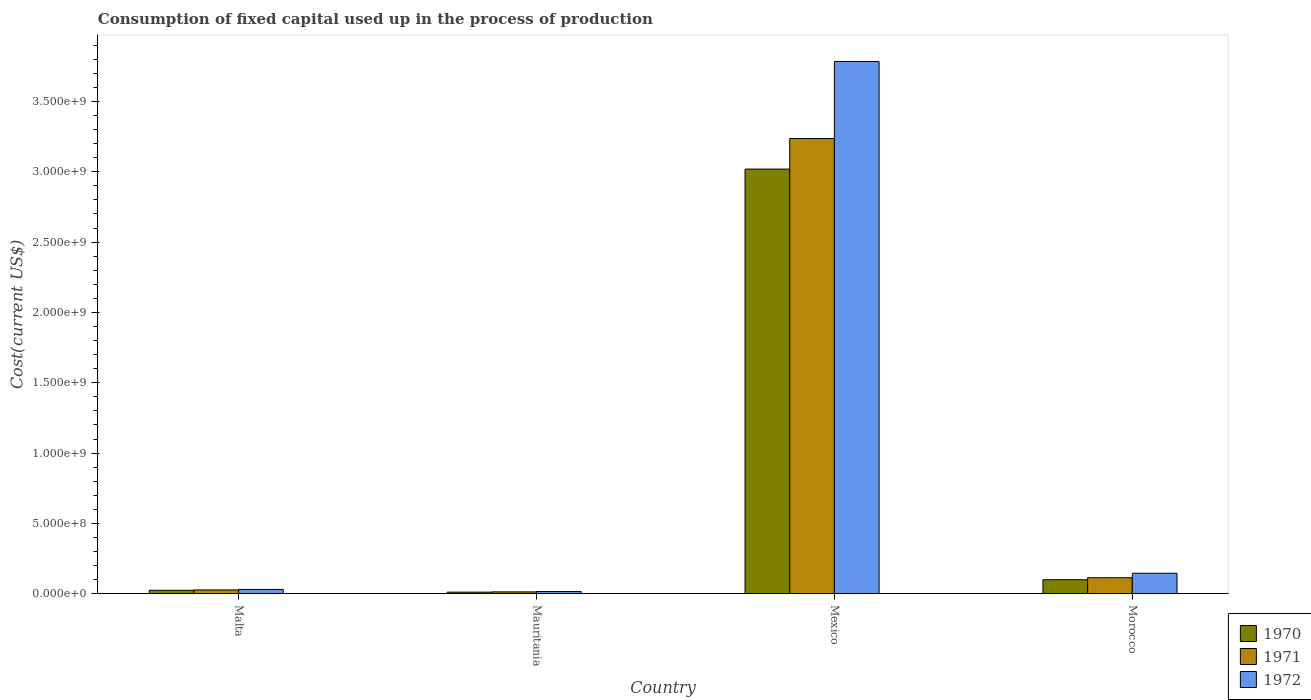In how many cases, is the number of bars for a given country not equal to the number of legend labels?
Give a very brief answer. 0. What is the amount consumed in the process of production in 1972 in Mauritania?
Your answer should be compact. 1.58e+07. Across all countries, what is the maximum amount consumed in the process of production in 1970?
Give a very brief answer. 3.02e+09. Across all countries, what is the minimum amount consumed in the process of production in 1971?
Offer a very short reply. 1.33e+07. In which country was the amount consumed in the process of production in 1970 minimum?
Your answer should be very brief. Mauritania. What is the total amount consumed in the process of production in 1971 in the graph?
Keep it short and to the point. 3.39e+09. What is the difference between the amount consumed in the process of production in 1971 in Mauritania and that in Mexico?
Offer a terse response. -3.22e+09. What is the difference between the amount consumed in the process of production in 1972 in Mexico and the amount consumed in the process of production in 1970 in Mauritania?
Ensure brevity in your answer.  3.77e+09. What is the average amount consumed in the process of production in 1970 per country?
Your answer should be compact. 7.89e+08. What is the difference between the amount consumed in the process of production of/in 1971 and amount consumed in the process of production of/in 1970 in Mauritania?
Offer a very short reply. 1.80e+06. In how many countries, is the amount consumed in the process of production in 1971 greater than 800000000 US$?
Your response must be concise. 1. What is the ratio of the amount consumed in the process of production in 1970 in Mauritania to that in Morocco?
Keep it short and to the point. 0.12. Is the difference between the amount consumed in the process of production in 1971 in Malta and Mexico greater than the difference between the amount consumed in the process of production in 1970 in Malta and Mexico?
Provide a short and direct response. No. What is the difference between the highest and the second highest amount consumed in the process of production in 1971?
Ensure brevity in your answer.  3.12e+09. What is the difference between the highest and the lowest amount consumed in the process of production in 1972?
Offer a very short reply. 3.77e+09. How many bars are there?
Make the answer very short. 12. Are all the bars in the graph horizontal?
Provide a short and direct response. No. Are the values on the major ticks of Y-axis written in scientific E-notation?
Ensure brevity in your answer.  Yes. Does the graph contain grids?
Offer a terse response. No. Where does the legend appear in the graph?
Provide a short and direct response. Bottom right. How are the legend labels stacked?
Provide a short and direct response. Vertical. What is the title of the graph?
Provide a short and direct response. Consumption of fixed capital used up in the process of production. What is the label or title of the Y-axis?
Provide a succinct answer. Cost(current US$). What is the Cost(current US$) in 1970 in Malta?
Provide a short and direct response. 2.47e+07. What is the Cost(current US$) of 1971 in Malta?
Your answer should be compact. 2.71e+07. What is the Cost(current US$) in 1972 in Malta?
Give a very brief answer. 3.06e+07. What is the Cost(current US$) of 1970 in Mauritania?
Offer a very short reply. 1.15e+07. What is the Cost(current US$) of 1971 in Mauritania?
Give a very brief answer. 1.33e+07. What is the Cost(current US$) of 1972 in Mauritania?
Offer a very short reply. 1.58e+07. What is the Cost(current US$) in 1970 in Mexico?
Your response must be concise. 3.02e+09. What is the Cost(current US$) of 1971 in Mexico?
Keep it short and to the point. 3.24e+09. What is the Cost(current US$) in 1972 in Mexico?
Offer a very short reply. 3.78e+09. What is the Cost(current US$) of 1970 in Morocco?
Make the answer very short. 9.95e+07. What is the Cost(current US$) of 1971 in Morocco?
Your response must be concise. 1.14e+08. What is the Cost(current US$) in 1972 in Morocco?
Provide a short and direct response. 1.46e+08. Across all countries, what is the maximum Cost(current US$) in 1970?
Your answer should be compact. 3.02e+09. Across all countries, what is the maximum Cost(current US$) of 1971?
Provide a succinct answer. 3.24e+09. Across all countries, what is the maximum Cost(current US$) in 1972?
Provide a succinct answer. 3.78e+09. Across all countries, what is the minimum Cost(current US$) in 1970?
Offer a terse response. 1.15e+07. Across all countries, what is the minimum Cost(current US$) in 1971?
Provide a short and direct response. 1.33e+07. Across all countries, what is the minimum Cost(current US$) of 1972?
Make the answer very short. 1.58e+07. What is the total Cost(current US$) of 1970 in the graph?
Offer a very short reply. 3.15e+09. What is the total Cost(current US$) of 1971 in the graph?
Give a very brief answer. 3.39e+09. What is the total Cost(current US$) in 1972 in the graph?
Your answer should be very brief. 3.98e+09. What is the difference between the Cost(current US$) in 1970 in Malta and that in Mauritania?
Give a very brief answer. 1.33e+07. What is the difference between the Cost(current US$) in 1971 in Malta and that in Mauritania?
Offer a terse response. 1.38e+07. What is the difference between the Cost(current US$) in 1972 in Malta and that in Mauritania?
Offer a terse response. 1.48e+07. What is the difference between the Cost(current US$) in 1970 in Malta and that in Mexico?
Give a very brief answer. -2.99e+09. What is the difference between the Cost(current US$) of 1971 in Malta and that in Mexico?
Ensure brevity in your answer.  -3.21e+09. What is the difference between the Cost(current US$) in 1972 in Malta and that in Mexico?
Keep it short and to the point. -3.75e+09. What is the difference between the Cost(current US$) in 1970 in Malta and that in Morocco?
Give a very brief answer. -7.48e+07. What is the difference between the Cost(current US$) of 1971 in Malta and that in Morocco?
Your answer should be very brief. -8.68e+07. What is the difference between the Cost(current US$) in 1972 in Malta and that in Morocco?
Give a very brief answer. -1.15e+08. What is the difference between the Cost(current US$) of 1970 in Mauritania and that in Mexico?
Your answer should be compact. -3.01e+09. What is the difference between the Cost(current US$) in 1971 in Mauritania and that in Mexico?
Offer a very short reply. -3.22e+09. What is the difference between the Cost(current US$) in 1972 in Mauritania and that in Mexico?
Provide a short and direct response. -3.77e+09. What is the difference between the Cost(current US$) of 1970 in Mauritania and that in Morocco?
Your response must be concise. -8.80e+07. What is the difference between the Cost(current US$) in 1971 in Mauritania and that in Morocco?
Keep it short and to the point. -1.01e+08. What is the difference between the Cost(current US$) in 1972 in Mauritania and that in Morocco?
Offer a terse response. -1.30e+08. What is the difference between the Cost(current US$) of 1970 in Mexico and that in Morocco?
Offer a terse response. 2.92e+09. What is the difference between the Cost(current US$) of 1971 in Mexico and that in Morocco?
Your answer should be very brief. 3.12e+09. What is the difference between the Cost(current US$) in 1972 in Mexico and that in Morocco?
Provide a succinct answer. 3.64e+09. What is the difference between the Cost(current US$) in 1970 in Malta and the Cost(current US$) in 1971 in Mauritania?
Provide a short and direct response. 1.15e+07. What is the difference between the Cost(current US$) of 1970 in Malta and the Cost(current US$) of 1972 in Mauritania?
Provide a short and direct response. 8.89e+06. What is the difference between the Cost(current US$) of 1971 in Malta and the Cost(current US$) of 1972 in Mauritania?
Ensure brevity in your answer.  1.12e+07. What is the difference between the Cost(current US$) of 1970 in Malta and the Cost(current US$) of 1971 in Mexico?
Make the answer very short. -3.21e+09. What is the difference between the Cost(current US$) in 1970 in Malta and the Cost(current US$) in 1972 in Mexico?
Offer a terse response. -3.76e+09. What is the difference between the Cost(current US$) of 1971 in Malta and the Cost(current US$) of 1972 in Mexico?
Offer a very short reply. -3.76e+09. What is the difference between the Cost(current US$) in 1970 in Malta and the Cost(current US$) in 1971 in Morocco?
Your response must be concise. -8.92e+07. What is the difference between the Cost(current US$) of 1970 in Malta and the Cost(current US$) of 1972 in Morocco?
Your response must be concise. -1.21e+08. What is the difference between the Cost(current US$) of 1971 in Malta and the Cost(current US$) of 1972 in Morocco?
Provide a short and direct response. -1.19e+08. What is the difference between the Cost(current US$) in 1970 in Mauritania and the Cost(current US$) in 1971 in Mexico?
Offer a very short reply. -3.22e+09. What is the difference between the Cost(current US$) of 1970 in Mauritania and the Cost(current US$) of 1972 in Mexico?
Make the answer very short. -3.77e+09. What is the difference between the Cost(current US$) of 1971 in Mauritania and the Cost(current US$) of 1972 in Mexico?
Offer a terse response. -3.77e+09. What is the difference between the Cost(current US$) in 1970 in Mauritania and the Cost(current US$) in 1971 in Morocco?
Your response must be concise. -1.02e+08. What is the difference between the Cost(current US$) of 1970 in Mauritania and the Cost(current US$) of 1972 in Morocco?
Keep it short and to the point. -1.34e+08. What is the difference between the Cost(current US$) in 1971 in Mauritania and the Cost(current US$) in 1972 in Morocco?
Make the answer very short. -1.33e+08. What is the difference between the Cost(current US$) of 1970 in Mexico and the Cost(current US$) of 1971 in Morocco?
Keep it short and to the point. 2.91e+09. What is the difference between the Cost(current US$) of 1970 in Mexico and the Cost(current US$) of 1972 in Morocco?
Your answer should be compact. 2.87e+09. What is the difference between the Cost(current US$) of 1971 in Mexico and the Cost(current US$) of 1972 in Morocco?
Your answer should be very brief. 3.09e+09. What is the average Cost(current US$) in 1970 per country?
Offer a terse response. 7.89e+08. What is the average Cost(current US$) in 1971 per country?
Your answer should be compact. 8.48e+08. What is the average Cost(current US$) of 1972 per country?
Your answer should be compact. 9.94e+08. What is the difference between the Cost(current US$) of 1970 and Cost(current US$) of 1971 in Malta?
Ensure brevity in your answer.  -2.36e+06. What is the difference between the Cost(current US$) of 1970 and Cost(current US$) of 1972 in Malta?
Your answer should be very brief. -5.93e+06. What is the difference between the Cost(current US$) of 1971 and Cost(current US$) of 1972 in Malta?
Keep it short and to the point. -3.58e+06. What is the difference between the Cost(current US$) of 1970 and Cost(current US$) of 1971 in Mauritania?
Your answer should be compact. -1.80e+06. What is the difference between the Cost(current US$) in 1970 and Cost(current US$) in 1972 in Mauritania?
Provide a succinct answer. -4.37e+06. What is the difference between the Cost(current US$) in 1971 and Cost(current US$) in 1972 in Mauritania?
Offer a very short reply. -2.57e+06. What is the difference between the Cost(current US$) of 1970 and Cost(current US$) of 1971 in Mexico?
Provide a short and direct response. -2.17e+08. What is the difference between the Cost(current US$) in 1970 and Cost(current US$) in 1972 in Mexico?
Offer a very short reply. -7.65e+08. What is the difference between the Cost(current US$) in 1971 and Cost(current US$) in 1972 in Mexico?
Offer a very short reply. -5.48e+08. What is the difference between the Cost(current US$) of 1970 and Cost(current US$) of 1971 in Morocco?
Offer a very short reply. -1.44e+07. What is the difference between the Cost(current US$) of 1970 and Cost(current US$) of 1972 in Morocco?
Your response must be concise. -4.63e+07. What is the difference between the Cost(current US$) in 1971 and Cost(current US$) in 1972 in Morocco?
Your answer should be compact. -3.18e+07. What is the ratio of the Cost(current US$) of 1970 in Malta to that in Mauritania?
Offer a very short reply. 2.16. What is the ratio of the Cost(current US$) of 1971 in Malta to that in Mauritania?
Provide a short and direct response. 2.04. What is the ratio of the Cost(current US$) of 1972 in Malta to that in Mauritania?
Your answer should be very brief. 1.94. What is the ratio of the Cost(current US$) in 1970 in Malta to that in Mexico?
Make the answer very short. 0.01. What is the ratio of the Cost(current US$) in 1971 in Malta to that in Mexico?
Your response must be concise. 0.01. What is the ratio of the Cost(current US$) in 1972 in Malta to that in Mexico?
Ensure brevity in your answer.  0.01. What is the ratio of the Cost(current US$) of 1970 in Malta to that in Morocco?
Ensure brevity in your answer.  0.25. What is the ratio of the Cost(current US$) of 1971 in Malta to that in Morocco?
Provide a succinct answer. 0.24. What is the ratio of the Cost(current US$) of 1972 in Malta to that in Morocco?
Your answer should be very brief. 0.21. What is the ratio of the Cost(current US$) in 1970 in Mauritania to that in Mexico?
Offer a very short reply. 0. What is the ratio of the Cost(current US$) in 1971 in Mauritania to that in Mexico?
Make the answer very short. 0. What is the ratio of the Cost(current US$) of 1972 in Mauritania to that in Mexico?
Your answer should be very brief. 0. What is the ratio of the Cost(current US$) in 1970 in Mauritania to that in Morocco?
Provide a short and direct response. 0.12. What is the ratio of the Cost(current US$) of 1971 in Mauritania to that in Morocco?
Offer a very short reply. 0.12. What is the ratio of the Cost(current US$) in 1972 in Mauritania to that in Morocco?
Keep it short and to the point. 0.11. What is the ratio of the Cost(current US$) in 1970 in Mexico to that in Morocco?
Your answer should be compact. 30.34. What is the ratio of the Cost(current US$) of 1971 in Mexico to that in Morocco?
Offer a terse response. 28.41. What is the ratio of the Cost(current US$) of 1972 in Mexico to that in Morocco?
Offer a very short reply. 25.96. What is the difference between the highest and the second highest Cost(current US$) of 1970?
Offer a very short reply. 2.92e+09. What is the difference between the highest and the second highest Cost(current US$) of 1971?
Your response must be concise. 3.12e+09. What is the difference between the highest and the second highest Cost(current US$) in 1972?
Offer a terse response. 3.64e+09. What is the difference between the highest and the lowest Cost(current US$) of 1970?
Provide a short and direct response. 3.01e+09. What is the difference between the highest and the lowest Cost(current US$) in 1971?
Your answer should be compact. 3.22e+09. What is the difference between the highest and the lowest Cost(current US$) of 1972?
Your answer should be compact. 3.77e+09. 